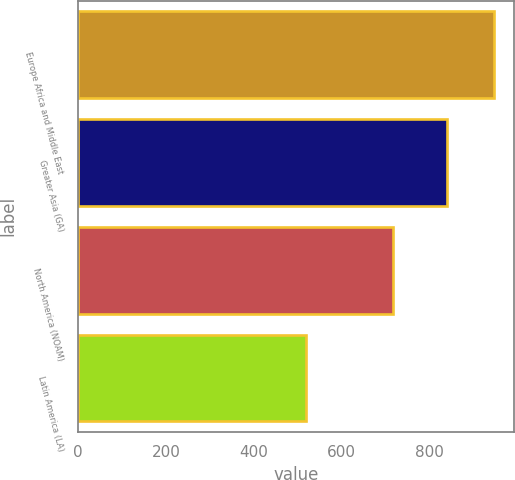Convert chart. <chart><loc_0><loc_0><loc_500><loc_500><bar_chart><fcel>Europe Africa and Middle East<fcel>Greater Asia (GA)<fcel>North America (NOAM)<fcel>Latin America (LA)<nl><fcel>946<fcel>839<fcel>718<fcel>520<nl></chart> 